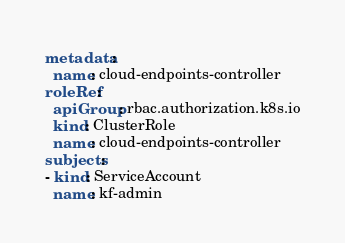<code> <loc_0><loc_0><loc_500><loc_500><_YAML_>metadata:
  name: cloud-endpoints-controller
roleRef:
  apiGroup: rbac.authorization.k8s.io
  kind: ClusterRole
  name: cloud-endpoints-controller
subjects:
- kind: ServiceAccount
  name: kf-admin
</code> 